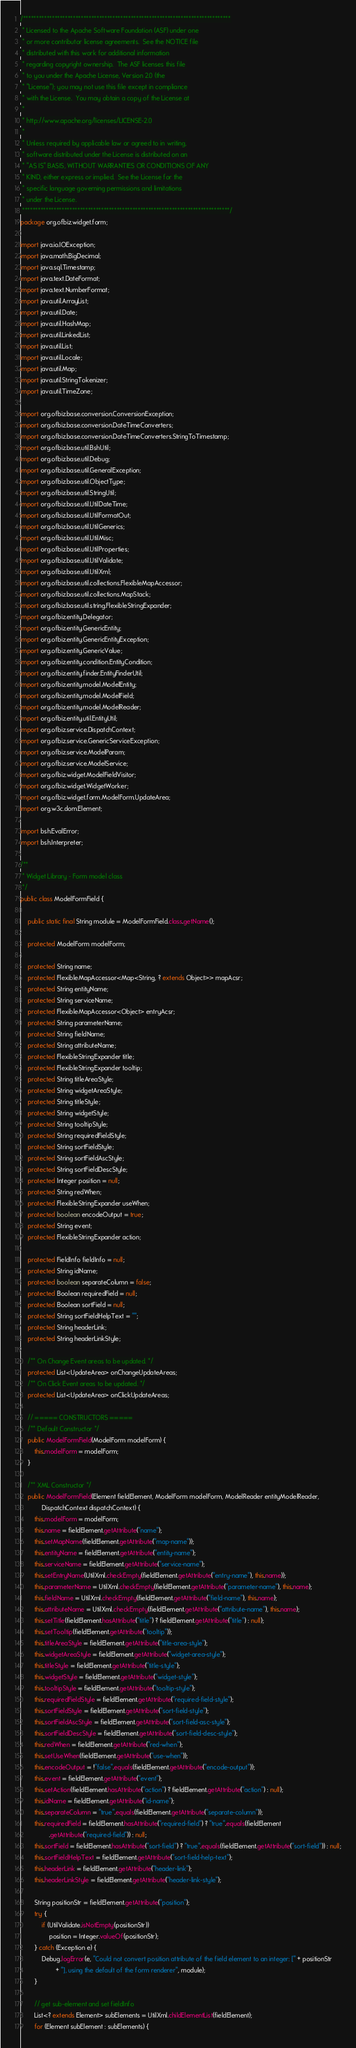<code> <loc_0><loc_0><loc_500><loc_500><_Java_>/*******************************************************************************
 * Licensed to the Apache Software Foundation (ASF) under one
 * or more contributor license agreements.  See the NOTICE file
 * distributed with this work for additional information
 * regarding copyright ownership.  The ASF licenses this file
 * to you under the Apache License, Version 2.0 (the
 * "License"); you may not use this file except in compliance
 * with the License.  You may obtain a copy of the License at
 *
 * http://www.apache.org/licenses/LICENSE-2.0
 *
 * Unless required by applicable law or agreed to in writing,
 * software distributed under the License is distributed on an
 * "AS IS" BASIS, WITHOUT WARRANTIES OR CONDITIONS OF ANY
 * KIND, either express or implied.  See the License for the
 * specific language governing permissions and limitations
 * under the License.
 *******************************************************************************/
package org.ofbiz.widget.form;

import java.io.IOException;
import java.math.BigDecimal;
import java.sql.Timestamp;
import java.text.DateFormat;
import java.text.NumberFormat;
import java.util.ArrayList;
import java.util.Date;
import java.util.HashMap;
import java.util.LinkedList;
import java.util.List;
import java.util.Locale;
import java.util.Map;
import java.util.StringTokenizer;
import java.util.TimeZone;

import org.ofbiz.base.conversion.ConversionException;
import org.ofbiz.base.conversion.DateTimeConverters;
import org.ofbiz.base.conversion.DateTimeConverters.StringToTimestamp;
import org.ofbiz.base.util.BshUtil;
import org.ofbiz.base.util.Debug;
import org.ofbiz.base.util.GeneralException;
import org.ofbiz.base.util.ObjectType;
import org.ofbiz.base.util.StringUtil;
import org.ofbiz.base.util.UtilDateTime;
import org.ofbiz.base.util.UtilFormatOut;
import org.ofbiz.base.util.UtilGenerics;
import org.ofbiz.base.util.UtilMisc;
import org.ofbiz.base.util.UtilProperties;
import org.ofbiz.base.util.UtilValidate;
import org.ofbiz.base.util.UtilXml;
import org.ofbiz.base.util.collections.FlexibleMapAccessor;
import org.ofbiz.base.util.collections.MapStack;
import org.ofbiz.base.util.string.FlexibleStringExpander;
import org.ofbiz.entity.Delegator;
import org.ofbiz.entity.GenericEntity;
import org.ofbiz.entity.GenericEntityException;
import org.ofbiz.entity.GenericValue;
import org.ofbiz.entity.condition.EntityCondition;
import org.ofbiz.entity.finder.EntityFinderUtil;
import org.ofbiz.entity.model.ModelEntity;
import org.ofbiz.entity.model.ModelField;
import org.ofbiz.entity.model.ModelReader;
import org.ofbiz.entity.util.EntityUtil;
import org.ofbiz.service.DispatchContext;
import org.ofbiz.service.GenericServiceException;
import org.ofbiz.service.ModelParam;
import org.ofbiz.service.ModelService;
import org.ofbiz.widget.ModelFieldVisitor;
import org.ofbiz.widget.WidgetWorker;
import org.ofbiz.widget.form.ModelForm.UpdateArea;
import org.w3c.dom.Element;

import bsh.EvalError;
import bsh.Interpreter;

/**
 * Widget Library - Form model class
 */
public class ModelFormField {

    public static final String module = ModelFormField.class.getName();

    protected ModelForm modelForm;

    protected String name;
    protected FlexibleMapAccessor<Map<String, ? extends Object>> mapAcsr;
    protected String entityName;
    protected String serviceName;
    protected FlexibleMapAccessor<Object> entryAcsr;
    protected String parameterName;
    protected String fieldName;
    protected String attributeName;
    protected FlexibleStringExpander title;
    protected FlexibleStringExpander tooltip;
    protected String titleAreaStyle;
    protected String widgetAreaStyle;
    protected String titleStyle;
    protected String widgetStyle;
    protected String tooltipStyle;
    protected String requiredFieldStyle;
    protected String sortFieldStyle;
    protected String sortFieldAscStyle;
    protected String sortFieldDescStyle;
    protected Integer position = null;
    protected String redWhen;
    protected FlexibleStringExpander useWhen;
    protected boolean encodeOutput = true;
    protected String event;
    protected FlexibleStringExpander action;

    protected FieldInfo fieldInfo = null;
    protected String idName;
    protected boolean separateColumn = false;
    protected Boolean requiredField = null;
    protected Boolean sortField = null;
    protected String sortFieldHelpText = "";
    protected String headerLink;
    protected String headerLinkStyle;

    /** On Change Event areas to be updated. */
    protected List<UpdateArea> onChangeUpdateAreas;
    /** On Click Event areas to be updated. */
    protected List<UpdateArea> onClickUpdateAreas;

    // ===== CONSTRUCTORS =====
    /** Default Constructor */
    public ModelFormField(ModelForm modelForm) {
        this.modelForm = modelForm;
    }

    /** XML Constructor */
    public ModelFormField(Element fieldElement, ModelForm modelForm, ModelReader entityModelReader,
            DispatchContext dispatchContext) {
        this.modelForm = modelForm;
        this.name = fieldElement.getAttribute("name");
        this.setMapName(fieldElement.getAttribute("map-name"));
        this.entityName = fieldElement.getAttribute("entity-name");
        this.serviceName = fieldElement.getAttribute("service-name");
        this.setEntryName(UtilXml.checkEmpty(fieldElement.getAttribute("entry-name"), this.name));
        this.parameterName = UtilXml.checkEmpty(fieldElement.getAttribute("parameter-name"), this.name);
        this.fieldName = UtilXml.checkEmpty(fieldElement.getAttribute("field-name"), this.name);
        this.attributeName = UtilXml.checkEmpty(fieldElement.getAttribute("attribute-name"), this.name);
        this.setTitle(fieldElement.hasAttribute("title") ? fieldElement.getAttribute("title") : null);
        this.setTooltip(fieldElement.getAttribute("tooltip"));
        this.titleAreaStyle = fieldElement.getAttribute("title-area-style");
        this.widgetAreaStyle = fieldElement.getAttribute("widget-area-style");
        this.titleStyle = fieldElement.getAttribute("title-style");
        this.widgetStyle = fieldElement.getAttribute("widget-style");
        this.tooltipStyle = fieldElement.getAttribute("tooltip-style");
        this.requiredFieldStyle = fieldElement.getAttribute("required-field-style");
        this.sortFieldStyle = fieldElement.getAttribute("sort-field-style");
        this.sortFieldAscStyle = fieldElement.getAttribute("sort-field-asc-style");
        this.sortFieldDescStyle = fieldElement.getAttribute("sort-field-desc-style");
        this.redWhen = fieldElement.getAttribute("red-when");
        this.setUseWhen(fieldElement.getAttribute("use-when"));
        this.encodeOutput = !"false".equals(fieldElement.getAttribute("encode-output"));
        this.event = fieldElement.getAttribute("event");
        this.setAction(fieldElement.hasAttribute("action") ? fieldElement.getAttribute("action") : null);
        this.idName = fieldElement.getAttribute("id-name");
        this.separateColumn = "true".equals(fieldElement.getAttribute("separate-column"));
        this.requiredField = fieldElement.hasAttribute("required-field") ? "true".equals(fieldElement
                .getAttribute("required-field")) : null;
        this.sortField = fieldElement.hasAttribute("sort-field") ? "true".equals(fieldElement.getAttribute("sort-field")) : null;
        this.sortFieldHelpText = fieldElement.getAttribute("sort-field-help-text");
        this.headerLink = fieldElement.getAttribute("header-link");
        this.headerLinkStyle = fieldElement.getAttribute("header-link-style");

        String positionStr = fieldElement.getAttribute("position");
        try {
            if (UtilValidate.isNotEmpty(positionStr))
                position = Integer.valueOf(positionStr);
        } catch (Exception e) {
            Debug.logError(e, "Could not convert position attribute of the field element to an integer: [" + positionStr
                    + "], using the default of the form renderer", module);
        }

        // get sub-element and set fieldInfo
        List<? extends Element> subElements = UtilXml.childElementList(fieldElement);
        for (Element subElement : subElements) {</code> 